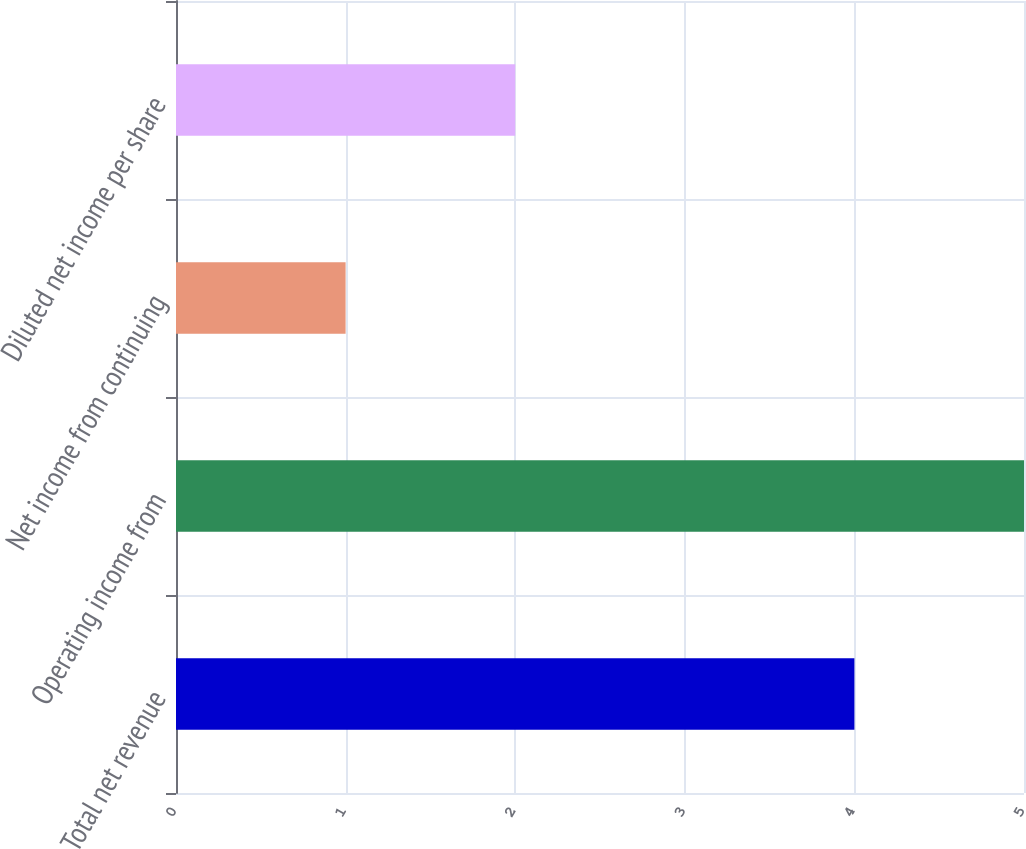Convert chart. <chart><loc_0><loc_0><loc_500><loc_500><bar_chart><fcel>Total net revenue<fcel>Operating income from<fcel>Net income from continuing<fcel>Diluted net income per share<nl><fcel>4<fcel>5<fcel>1<fcel>2<nl></chart> 